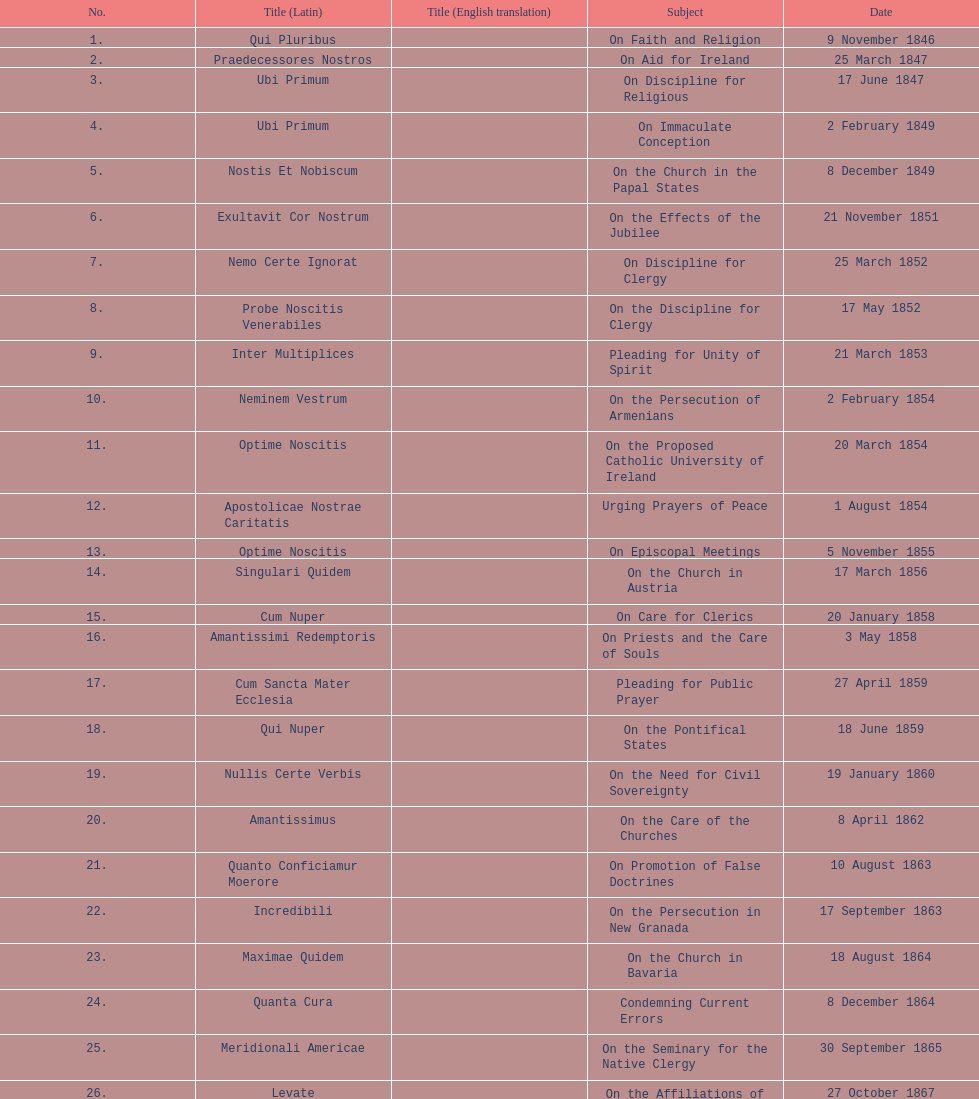Write the full table. {'header': ['No.', 'Title (Latin)', 'Title (English translation)', 'Subject', 'Date'], 'rows': [['1.', 'Qui Pluribus', '', 'On Faith and Religion', '9 November 1846'], ['2.', 'Praedecessores Nostros', '', 'On Aid for Ireland', '25 March 1847'], ['3.', 'Ubi Primum', '', 'On Discipline for Religious', '17 June 1847'], ['4.', 'Ubi Primum', '', 'On Immaculate Conception', '2 February 1849'], ['5.', 'Nostis Et Nobiscum', '', 'On the Church in the Papal States', '8 December 1849'], ['6.', 'Exultavit Cor Nostrum', '', 'On the Effects of the Jubilee', '21 November 1851'], ['7.', 'Nemo Certe Ignorat', '', 'On Discipline for Clergy', '25 March 1852'], ['8.', 'Probe Noscitis Venerabiles', '', 'On the Discipline for Clergy', '17 May 1852'], ['9.', 'Inter Multiplices', '', 'Pleading for Unity of Spirit', '21 March 1853'], ['10.', 'Neminem Vestrum', '', 'On the Persecution of Armenians', '2 February 1854'], ['11.', 'Optime Noscitis', '', 'On the Proposed Catholic University of Ireland', '20 March 1854'], ['12.', 'Apostolicae Nostrae Caritatis', '', 'Urging Prayers of Peace', '1 August 1854'], ['13.', 'Optime Noscitis', '', 'On Episcopal Meetings', '5 November 1855'], ['14.', 'Singulari Quidem', '', 'On the Church in Austria', '17 March 1856'], ['15.', 'Cum Nuper', '', 'On Care for Clerics', '20 January 1858'], ['16.', 'Amantissimi Redemptoris', '', 'On Priests and the Care of Souls', '3 May 1858'], ['17.', 'Cum Sancta Mater Ecclesia', '', 'Pleading for Public Prayer', '27 April 1859'], ['18.', 'Qui Nuper', '', 'On the Pontifical States', '18 June 1859'], ['19.', 'Nullis Certe Verbis', '', 'On the Need for Civil Sovereignty', '19 January 1860'], ['20.', 'Amantissimus', '', 'On the Care of the Churches', '8 April 1862'], ['21.', 'Quanto Conficiamur Moerore', '', 'On Promotion of False Doctrines', '10 August 1863'], ['22.', 'Incredibili', '', 'On the Persecution in New Granada', '17 September 1863'], ['23.', 'Maximae Quidem', '', 'On the Church in Bavaria', '18 August 1864'], ['24.', 'Quanta Cura', '', 'Condemning Current Errors', '8 December 1864'], ['25.', 'Meridionali Americae', '', 'On the Seminary for the Native Clergy', '30 September 1865'], ['26.', 'Levate', '', 'On the Affiliations of Church', '27 October 1867'], ['27.', 'Respicientes', '', 'Protesting the Taking of the Pontifical States', '1 November 1870'], ['28.', 'Ubi Nos', '"Our City"', 'On the Pontifical States', '15 May 1871'], ['29.', 'Beneficia Dei', '', 'On the 25th Anniversary of His Pontificate', '4 June 1871'], ['30.', 'Saepe Venerabiles Fratres', '', 'Thanksgiving for 25 Years of Pontificate', '5 August 1871'], ['31.', 'Quae In Patriarchatu', '', 'On the Church in Chaldea', '16 November 1872'], ['32.', 'Quartus Supra', '', 'On the Church in Armenia', 'January 1873'], ['33.', 'Etsi Multa', '', 'On the Church in Italy, Germany and Switzerland', '21 November 1873'], ['34.', 'Vix Dum A Nobis', '', 'On the Church in Austria', '7 March 1874'], ['35.', 'Omnem Sollicitudinem', '', 'On the Greek-Ruthenian Rite', '13 May 1874'], ['36.', 'Gravibus Ecclesiae', '', 'Proclaiming A Jubilee', '24 December 1874'], ['37.', 'Quod Nunquam', '', 'On the Church in Prussia', '5 February 1875'], ['38.', 'Graves Ac Diuturnae', '', 'On the Church in Switzerland', '23 March 1875']]} During the initial decade of pope pius ix's rule, how many encyclicals did he release? 14. 